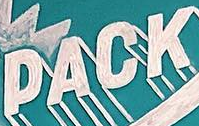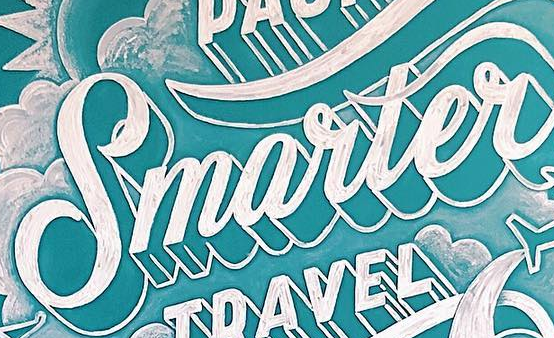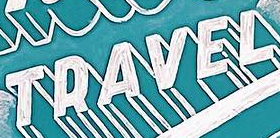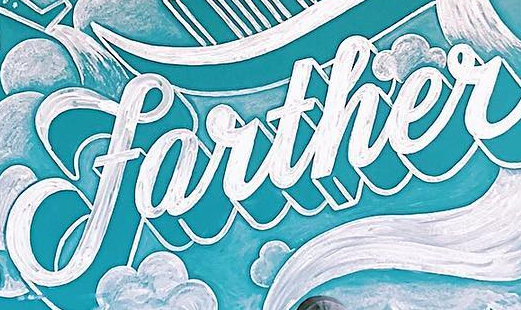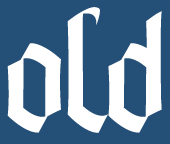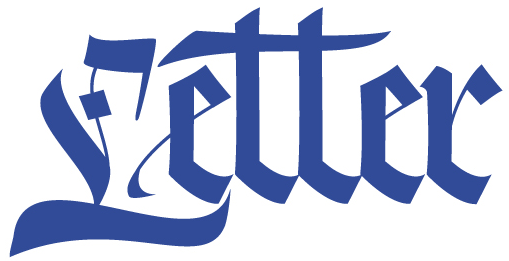What text is displayed in these images sequentially, separated by a semicolon? PACK; Smarter; TRAVEL; farther; old; Letter 